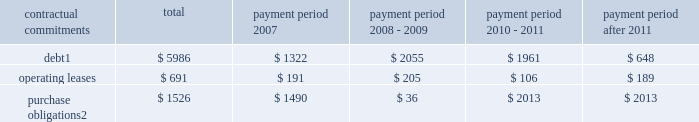Part ii , item 7 in 2006 , cash provided by financing activities was $ 291 million which was primarily due to the proceeds from employee stock plans ( $ 442 million ) and an increase in debt of $ 1.5 billion partially offset by the repurchase of 17.99 million shares of schlumberger stock ( $ 1.07 billion ) and the payment of dividends to shareholders ( $ 568 million ) .
Schlumberger believes that at december 31 , 2006 , cash and short-term investments of $ 3.0 billion and available and unused credit facilities of $ 2.2 billion are sufficient to meet future business requirements for at least the next twelve months .
Summary of major contractual commitments ( stated in millions ) .
Purchase obligations 2 $ 1526 $ 1490 $ 36 $ 2013 $ 2013 1 .
Excludes future payments for interest .
Includes amounts relating to the $ 1425 million of convertible debentures which are described in note 11 of the consolidated financial statements .
Represents an estimate of contractual obligations in the ordinary course of business .
Although these contractual obligations are considered enforceable and legally binding , the terms generally allow schlumberger the option to reschedule and adjust their requirements based on business needs prior to the delivery of goods .
Refer to note 4 of the consolidated financial statements for details regarding potential commitments associated with schlumberger 2019s prior business acquisitions .
Refer to note 20 of the consolidated financial statements for details regarding schlumberger 2019s pension and other postretirement benefit obligations .
Schlumberger has outstanding letters of credit/guarantees which relate to business performance bonds , custom/excise tax commitments , facility lease/rental obligations , etc .
These were entered into in the ordinary course of business and are customary practices in the various countries where schlumberger operates .
Critical accounting policies and estimates the preparation of financial statements and related disclosures in conformity with accounting principles generally accepted in the united states requires schlumberger to make estimates and assumptions that affect the reported amounts of assets and liabilities , the disclosure of contingent assets and liabilities and the reported amounts of revenue and expenses .
The following accounting policies involve 201ccritical accounting estimates 201d because they are particularly dependent on estimates and assumptions made by schlumberger about matters that are inherently uncertain .
A summary of all of schlumberger 2019s significant accounting policies is included in note 2 to the consolidated financial statements .
Schlumberger bases its estimates on historical experience and on various other assumptions that are believed to be reasonable under the circumstances , the results of which form the basis for making judgments about the carrying values of assets and liabilities that are not readily apparent from other sources .
Actual results may differ from these estimates under different assumptions or conditions .
Multiclient seismic data the westerngeco segment capitalizes the costs associated with obtaining multiclient seismic data .
The carrying value of the multiclient seismic data library at december 31 , 2006 , 2005 and 2004 was $ 227 million , $ 222 million and $ 347 million , respectively .
Such costs are charged to cost of goods sold and services based on the percentage of the total costs to the estimated total revenue that schlumberger expects to receive from the sales of such data .
However , except as described below under 201cwesterngeco purchase accounting , 201d under no circumstance will an individual survey carry a net book value greater than a 4-year straight-lined amortized value. .
What percentage of debt repayment will take place during 2008-2009? 
Computations: (2055 / 5986)
Answer: 0.3433. 